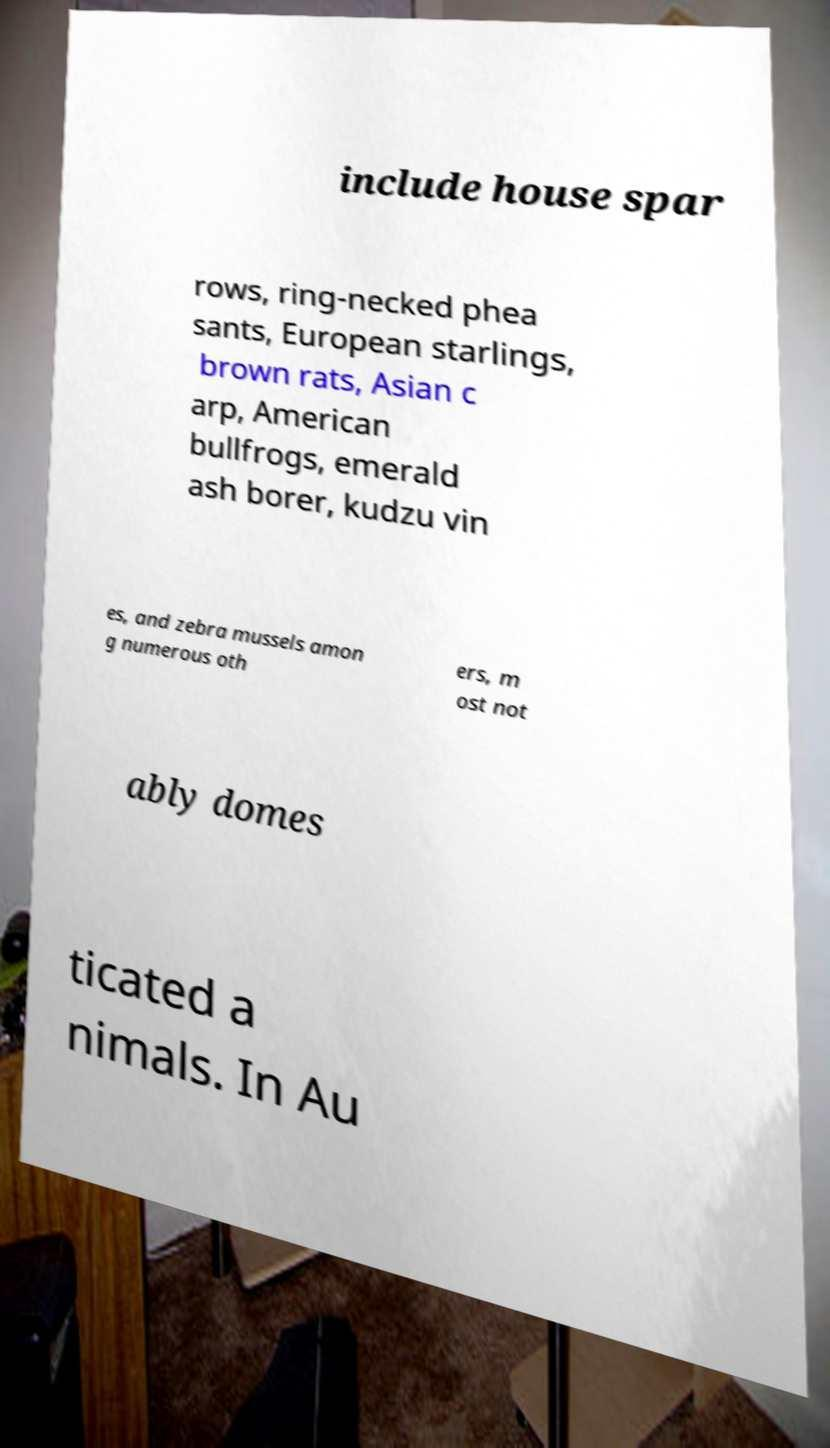What messages or text are displayed in this image? I need them in a readable, typed format. include house spar rows, ring-necked phea sants, European starlings, brown rats, Asian c arp, American bullfrogs, emerald ash borer, kudzu vin es, and zebra mussels amon g numerous oth ers, m ost not ably domes ticated a nimals. In Au 